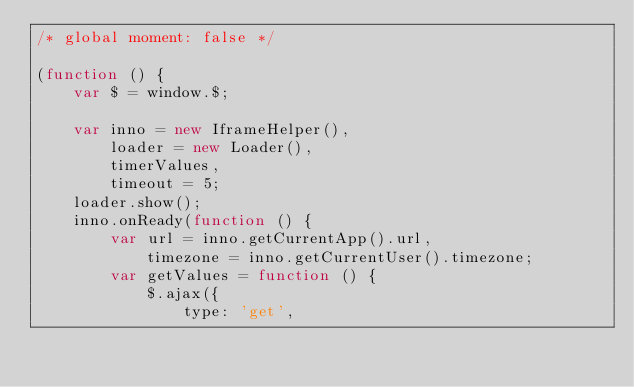<code> <loc_0><loc_0><loc_500><loc_500><_JavaScript_>/* global moment: false */

(function () {
    var $ = window.$;

    var inno = new IframeHelper(),
        loader = new Loader(),
        timerValues,
        timeout = 5;
    loader.show();
    inno.onReady(function () {
        var url = inno.getCurrentApp().url,
            timezone = inno.getCurrentUser().timezone;
        var getValues = function () {
            $.ajax({
                type: 'get',</code> 